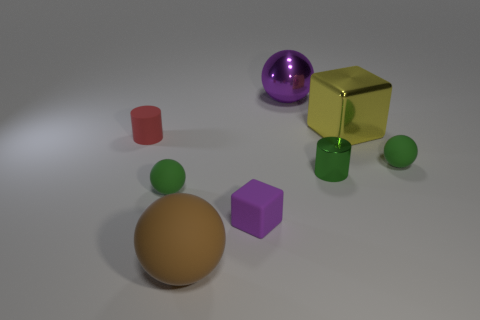Subtract all large purple shiny balls. How many balls are left? 3 Add 1 large green shiny blocks. How many objects exist? 9 Subtract all purple cubes. How many cubes are left? 1 Subtract 2 cylinders. How many cylinders are left? 0 Subtract all large yellow cubes. Subtract all large rubber things. How many objects are left? 6 Add 6 large brown rubber objects. How many large brown rubber objects are left? 7 Add 6 tiny green objects. How many tiny green objects exist? 9 Subtract 0 cyan cylinders. How many objects are left? 8 Subtract all cylinders. How many objects are left? 6 Subtract all cyan blocks. Subtract all gray cylinders. How many blocks are left? 2 